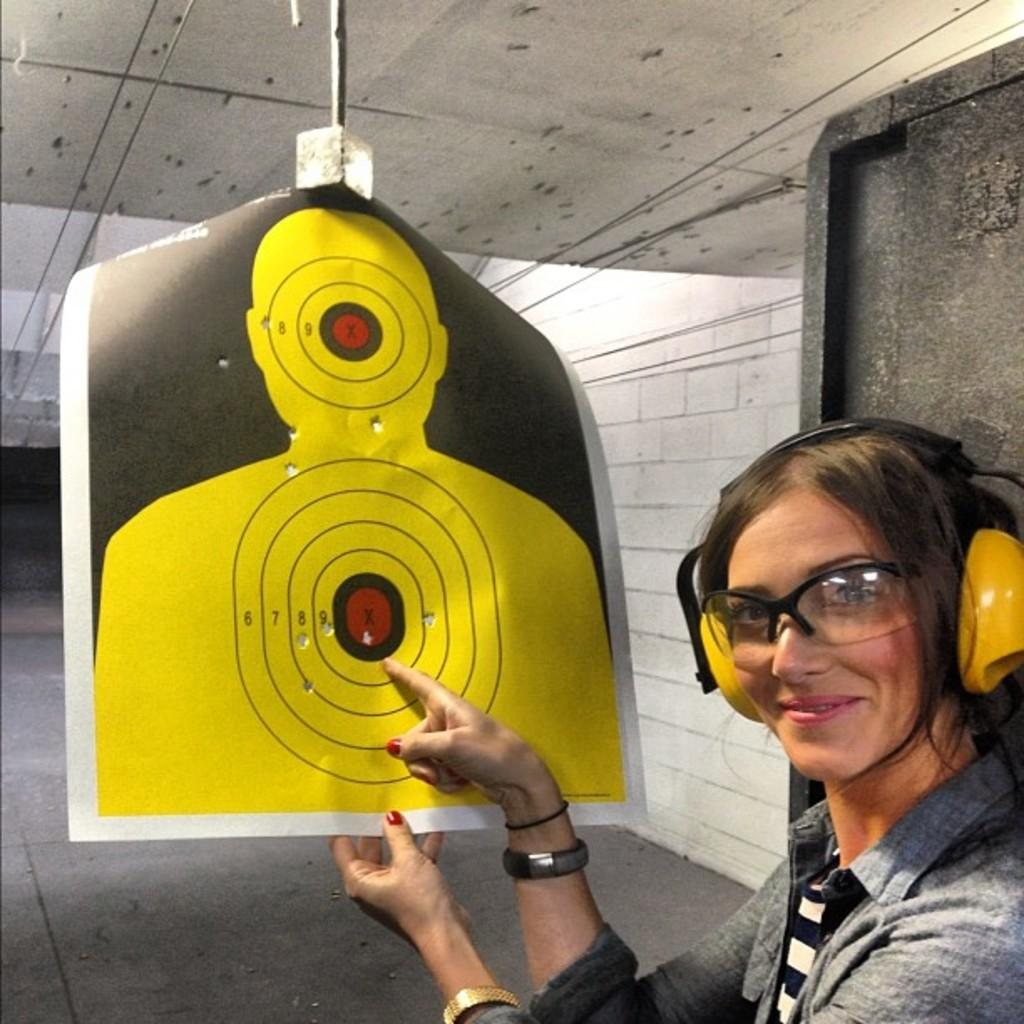Who is present on the right side of the image? There is a woman in the image on the right side. What is the woman wearing in the image? The woman is wearing a headset in the image. What can be seen in the background of the image? There is a wall, a floor, wires, and an object visible in the background of the image. How many cats are causing trouble in the image? There are no cats present in the image, and therefore no trouble can be attributed to them. 